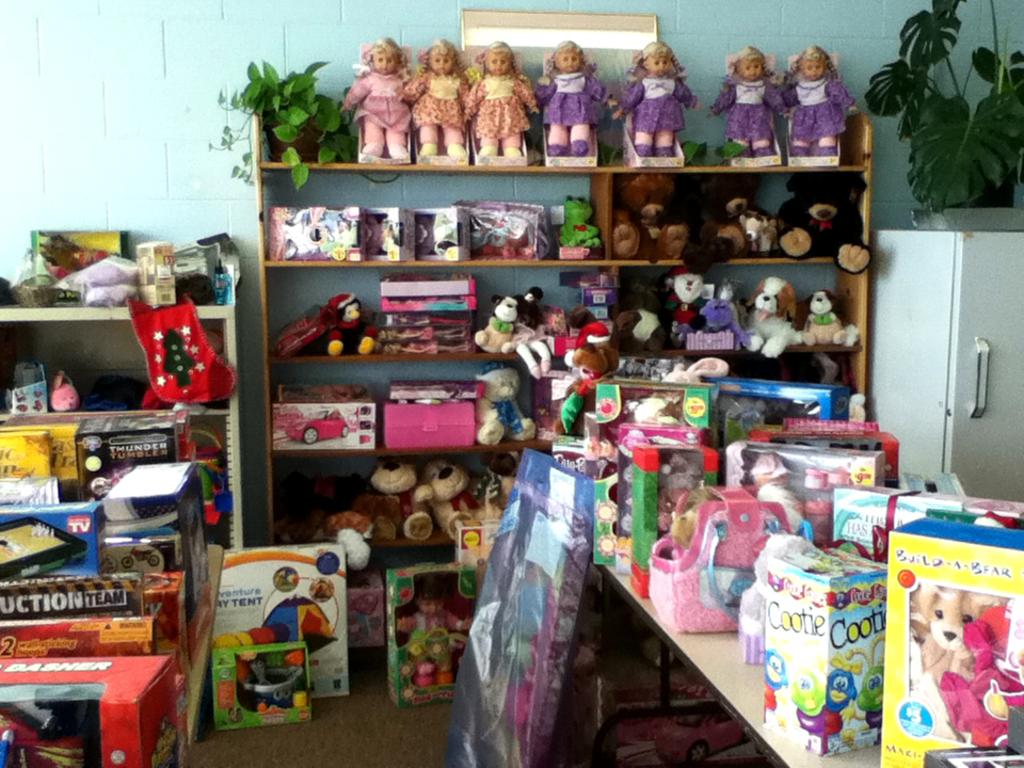What's the name of one of the board games?
Keep it short and to the point. Cootie. What is the name of the product is the nearby box on the right with the bugs on it?
Offer a terse response. Cootie. 